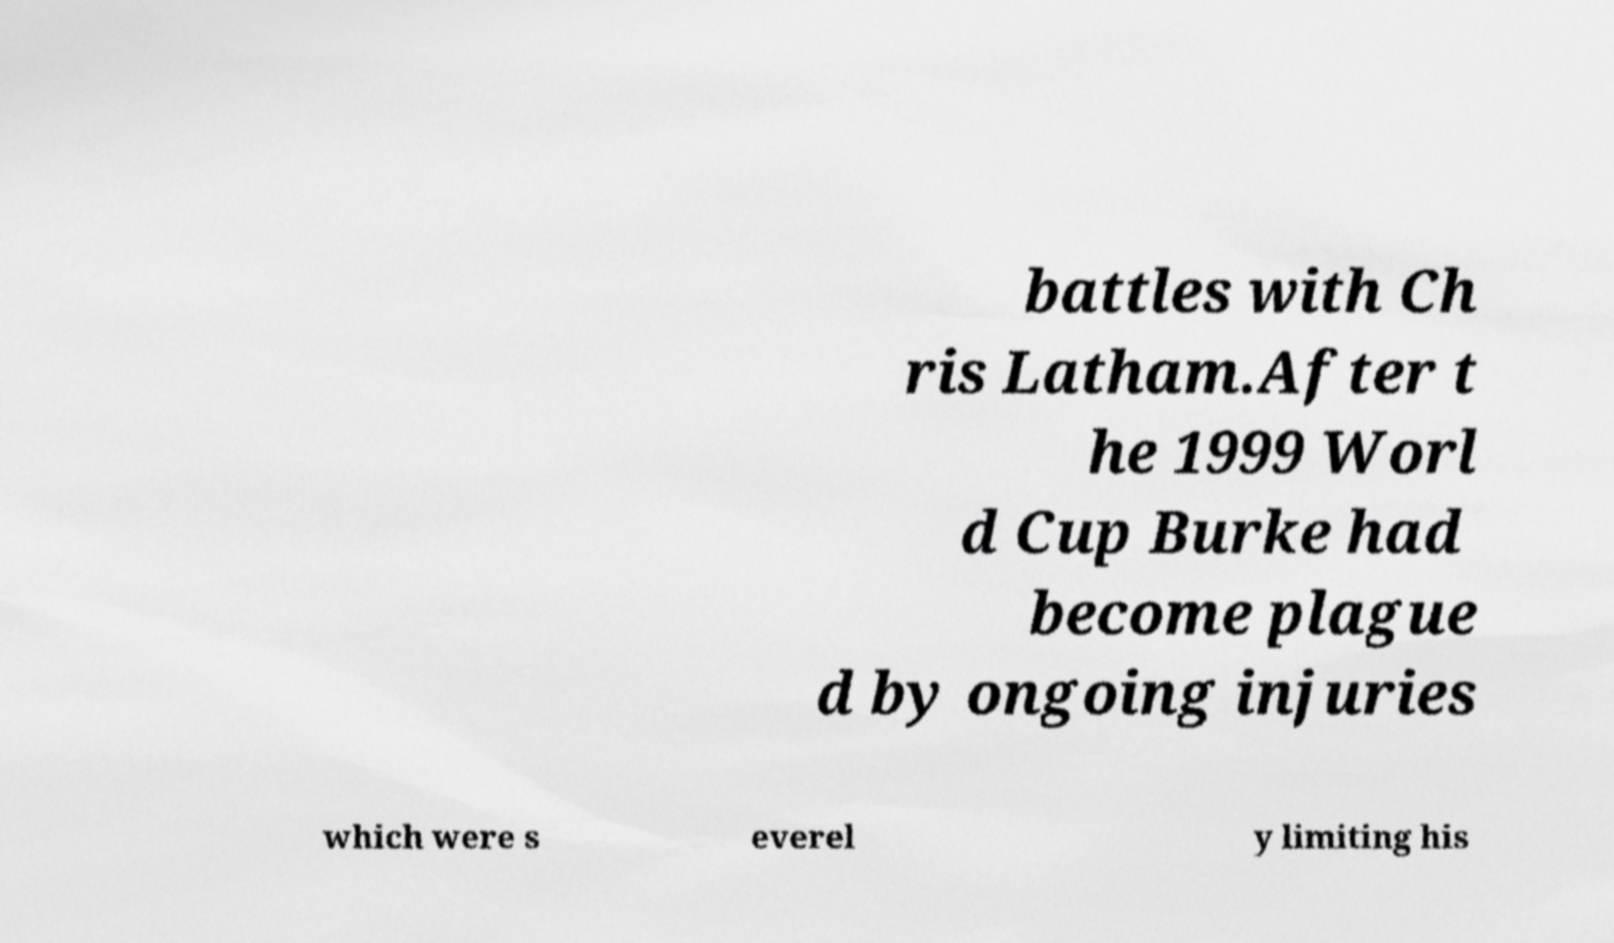Could you extract and type out the text from this image? battles with Ch ris Latham.After t he 1999 Worl d Cup Burke had become plague d by ongoing injuries which were s everel y limiting his 